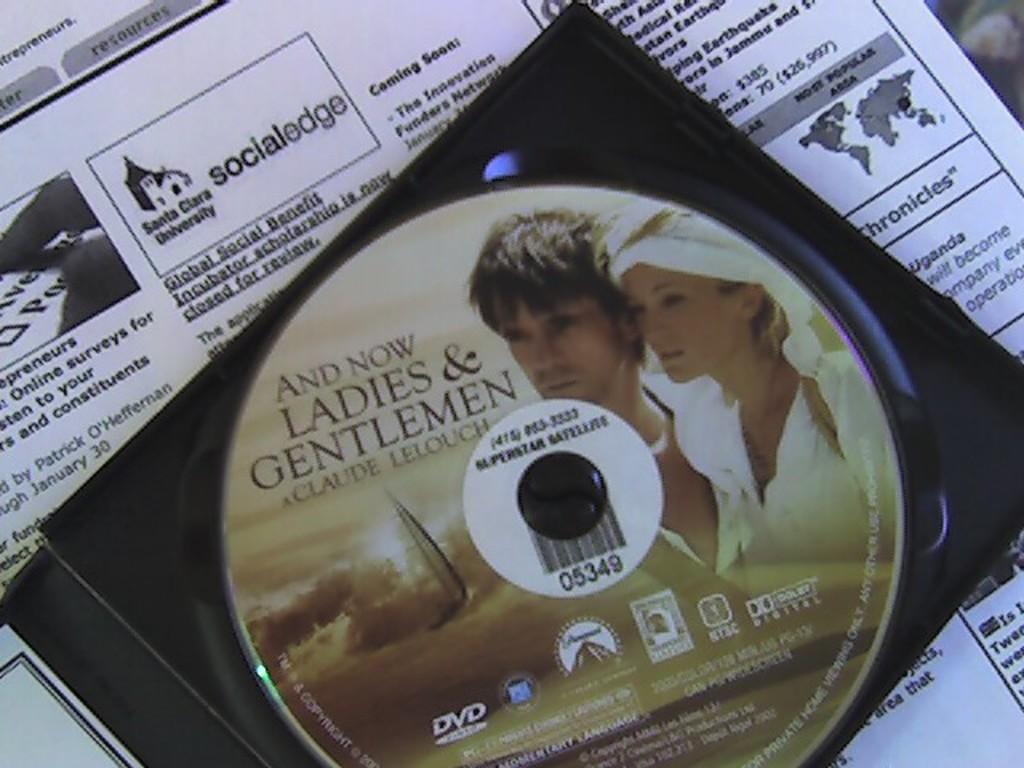In one or two sentences, can you explain what this image depicts? In this image there is a CD on the paper. 